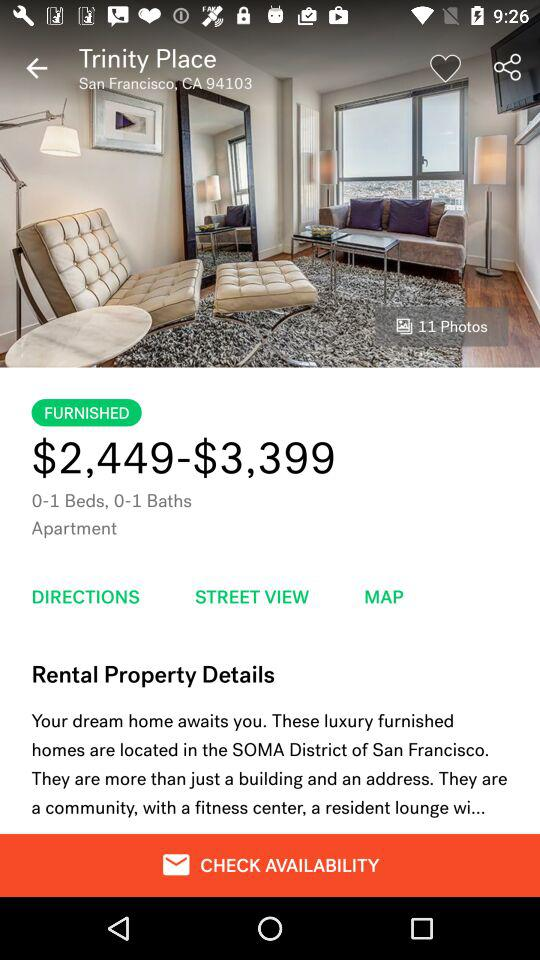How many beds does this apartment have?
Answer the question using a single word or phrase. 0-1 